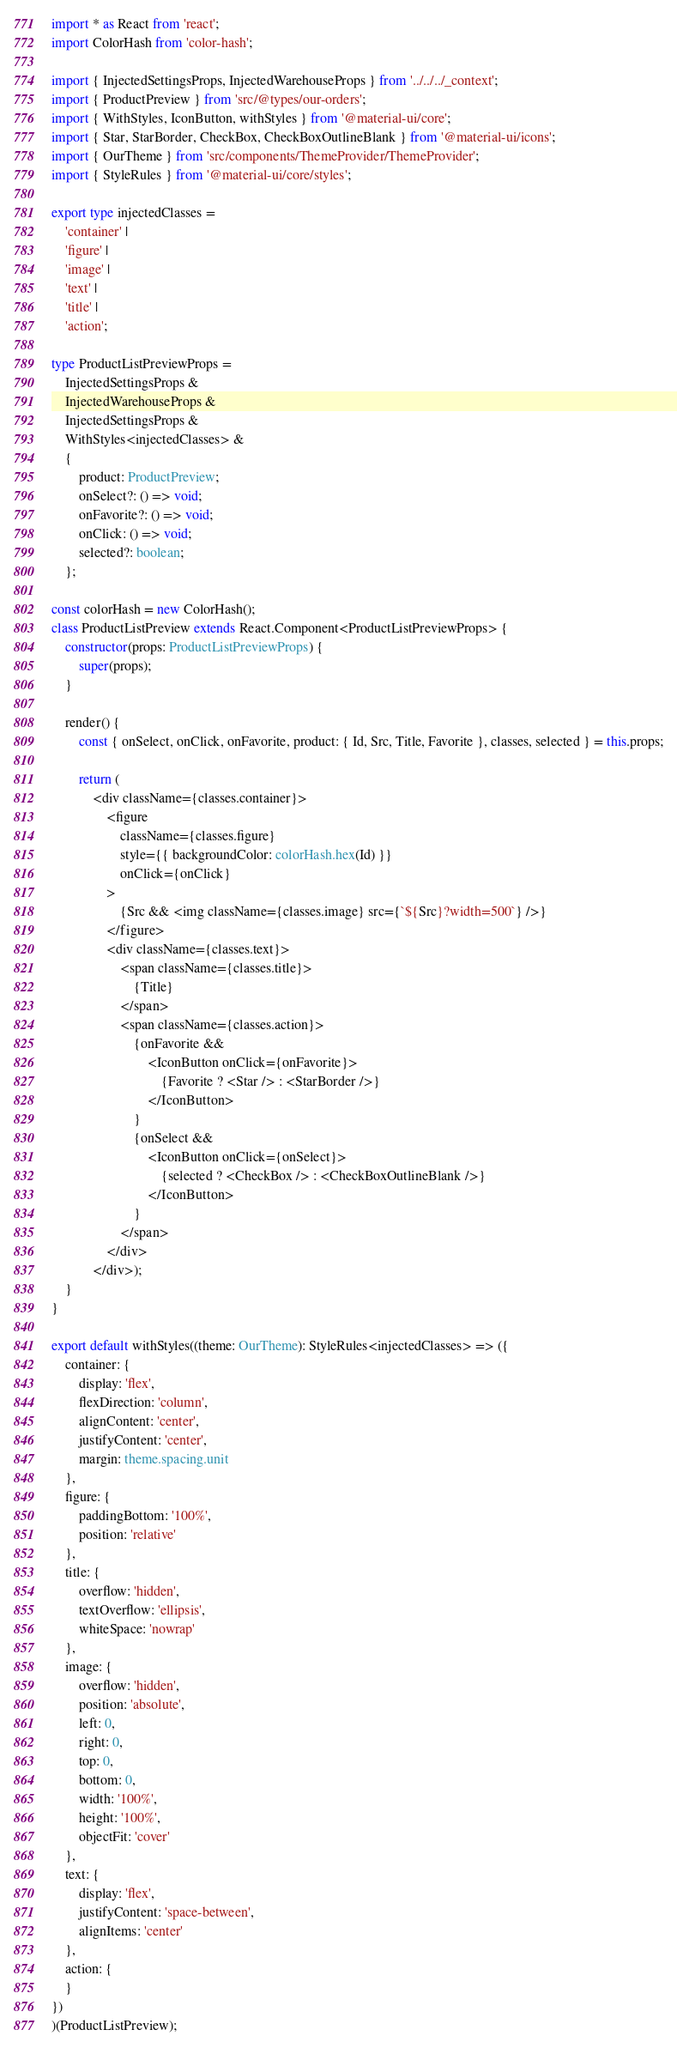<code> <loc_0><loc_0><loc_500><loc_500><_TypeScript_>import * as React from 'react';
import ColorHash from 'color-hash';

import { InjectedSettingsProps, InjectedWarehouseProps } from '../../../_context';
import { ProductPreview } from 'src/@types/our-orders';
import { WithStyles, IconButton, withStyles } from '@material-ui/core';
import { Star, StarBorder, CheckBox, CheckBoxOutlineBlank } from '@material-ui/icons';
import { OurTheme } from 'src/components/ThemeProvider/ThemeProvider';
import { StyleRules } from '@material-ui/core/styles';

export type injectedClasses =
    'container' |
    'figure' |
    'image' |
    'text' |
    'title' |
    'action';

type ProductListPreviewProps =
    InjectedSettingsProps &
    InjectedWarehouseProps &
    InjectedSettingsProps &
    WithStyles<injectedClasses> &
    {
        product: ProductPreview;
        onSelect?: () => void;
        onFavorite?: () => void;
        onClick: () => void;
        selected?: boolean;
    };

const colorHash = new ColorHash();
class ProductListPreview extends React.Component<ProductListPreviewProps> {
    constructor(props: ProductListPreviewProps) {
        super(props);
    }

    render() {
        const { onSelect, onClick, onFavorite, product: { Id, Src, Title, Favorite }, classes, selected } = this.props;

        return (
            <div className={classes.container}>
                <figure
                    className={classes.figure}
                    style={{ backgroundColor: colorHash.hex(Id) }}
                    onClick={onClick}
                >
                    {Src && <img className={classes.image} src={`${Src}?width=500`} />}
                </figure>
                <div className={classes.text}>
                    <span className={classes.title}>
                        {Title}
                    </span>
                    <span className={classes.action}>
                        {onFavorite &&
                            <IconButton onClick={onFavorite}>
                                {Favorite ? <Star /> : <StarBorder />}
                            </IconButton>
                        }
                        {onSelect &&
                            <IconButton onClick={onSelect}>
                                {selected ? <CheckBox /> : <CheckBoxOutlineBlank />}
                            </IconButton>
                        }
                    </span>
                </div>
            </div>);
    }
}

export default withStyles((theme: OurTheme): StyleRules<injectedClasses> => ({
    container: {
        display: 'flex',
        flexDirection: 'column',
        alignContent: 'center',
        justifyContent: 'center',
        margin: theme.spacing.unit
    },
    figure: {
        paddingBottom: '100%',
        position: 'relative'
    },
    title: {
        overflow: 'hidden',
        textOverflow: 'ellipsis',
        whiteSpace: 'nowrap'
    },
    image: {
        overflow: 'hidden',
        position: 'absolute',
        left: 0,
        right: 0,
        top: 0,
        bottom: 0,
        width: '100%',
        height: '100%',
        objectFit: 'cover'
    },
    text: {
        display: 'flex',
        justifyContent: 'space-between',
        alignItems: 'center'
    },
    action: {
    }
})
)(ProductListPreview);</code> 